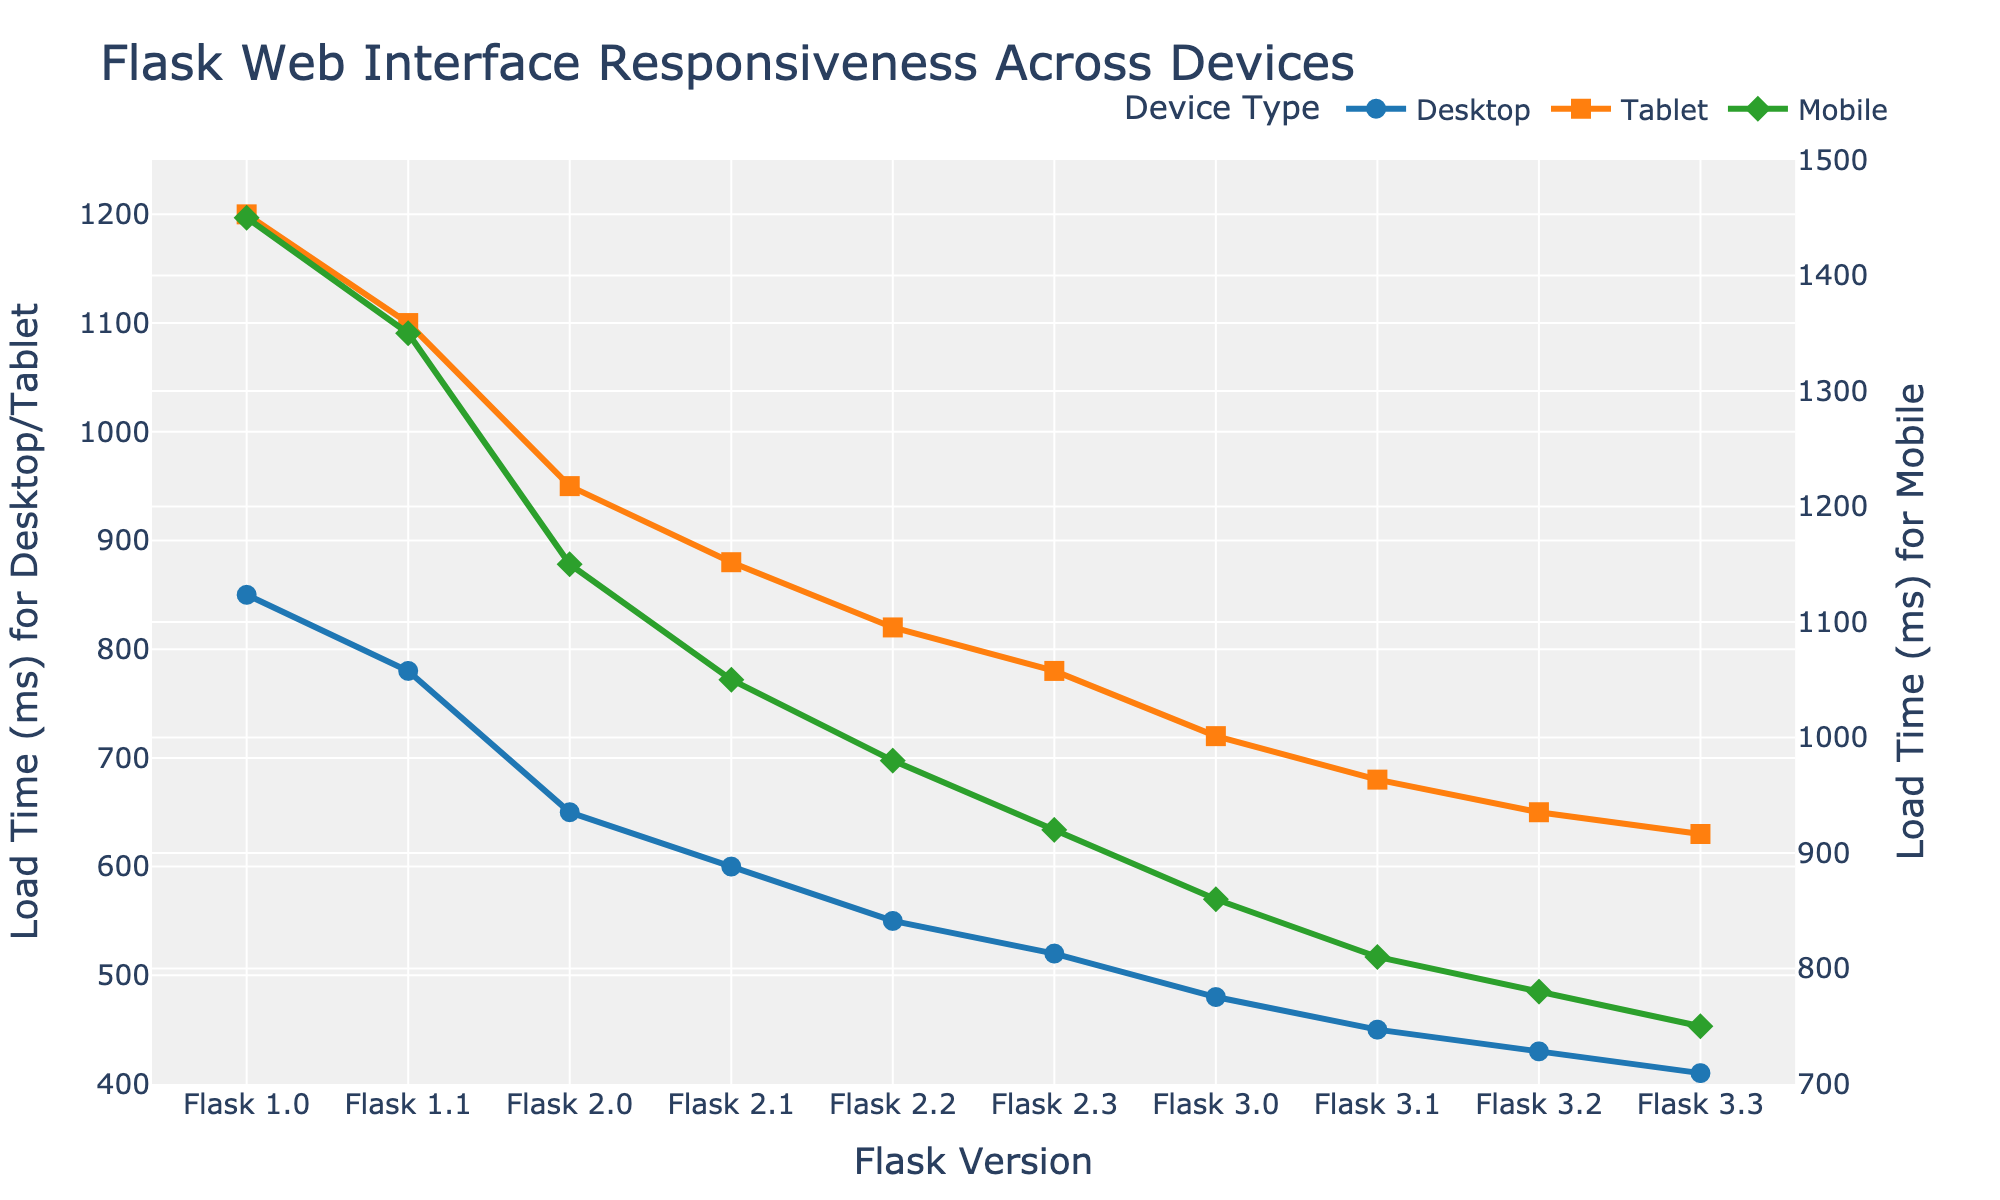What's the trend of load times for desktop devices across different Flask versions? The load times for desktop devices consistently decrease across versions from Flask 1.0 (850 ms) to Flask 3.3 (410 ms), indicating improvements in performance over time.
Answer: Decreasing Which Flask version shows the most significant improvement in load times for tablet devices compared to its previous version? The most significant improvement for tablets is observed from Flask 1.1 (1100 ms) to Flask 2.0 (950 ms), with a reduction of 150 ms.
Answer: Flask 2.0 At which Flask version do mobile devices achieve load times below 1000 ms? The load times for mobile devices fall below 1000 ms starting from Flask 2.2, which has a load time of 980 ms.
Answer: Flask 2.2 Compare the load times of desktop and mobile devices for Flask 3.0. Which one is faster and by how much? For Flask 3.0, the load time for desktop is 480 ms, and for mobile, it is 860 ms. Desktop is faster by 860 - 480 = 380 ms.
Answer: Desktop by 380 ms What is the average load time for mobile devices across all versions? The load times for mobile devices across all versions are: 1450, 1350, 1150, 1050, 980, 920, 860, 810, 780, and 750. The average is (1450 + 1350 + 1150 + 1050 + 980 + 920 + 860 + 810 + 780 + 750) / 10 = 1010 ms.
Answer: 1010 ms Do the load times for desktop devices ever surpass 900 ms after Flask 1.0? The load times for desktop devices after Flask 1.0 never surpass 900 ms. They are all below 850 ms starting from Flask 1.1.
Answer: No What is the percentage decrease in load times for tablet devices from Flask 1.0 to Flask 3.3? The load time for tablet devices decreases from 1200 ms in Flask 1.0 to 630 ms in Flask 3.3. The percentage decrease is ((1200 - 630) / 1200) * 100 = 47.5%.
Answer: 47.5% Which version has the smallest gap in load time between desktop and tablet devices, and what is the gap? The smallest gap between desktop and tablet is in Flask 3.2, where the desktop load time is 430 ms, and the tablet load time is 650 ms. The gap is 650 - 430 = 220 ms.
Answer: Flask 3.2, 220 ms How much faster is Flask 3.3 compared to Flask 2.0 for mobile devices? Flask 3.3 load time for mobile is 750 ms, while Flask 2.0 is 1150 ms. Flask 3.3 is 1150 - 750 = 400 ms faster.
Answer: 400 ms What is the overall trend for load times for mobile devices, and how does it compare to the trend for desktop devices? Both mobile and desktop devices show a consistent decreasing trend in load times, indicating overall responsiveness improvements. Mobile starts at 1450 ms in Flask 1.0 and reduces to 750 ms in Flask 3.3, while desktop starts at 850 ms and reduces to 410 ms.
Answer: Both are decreasing 